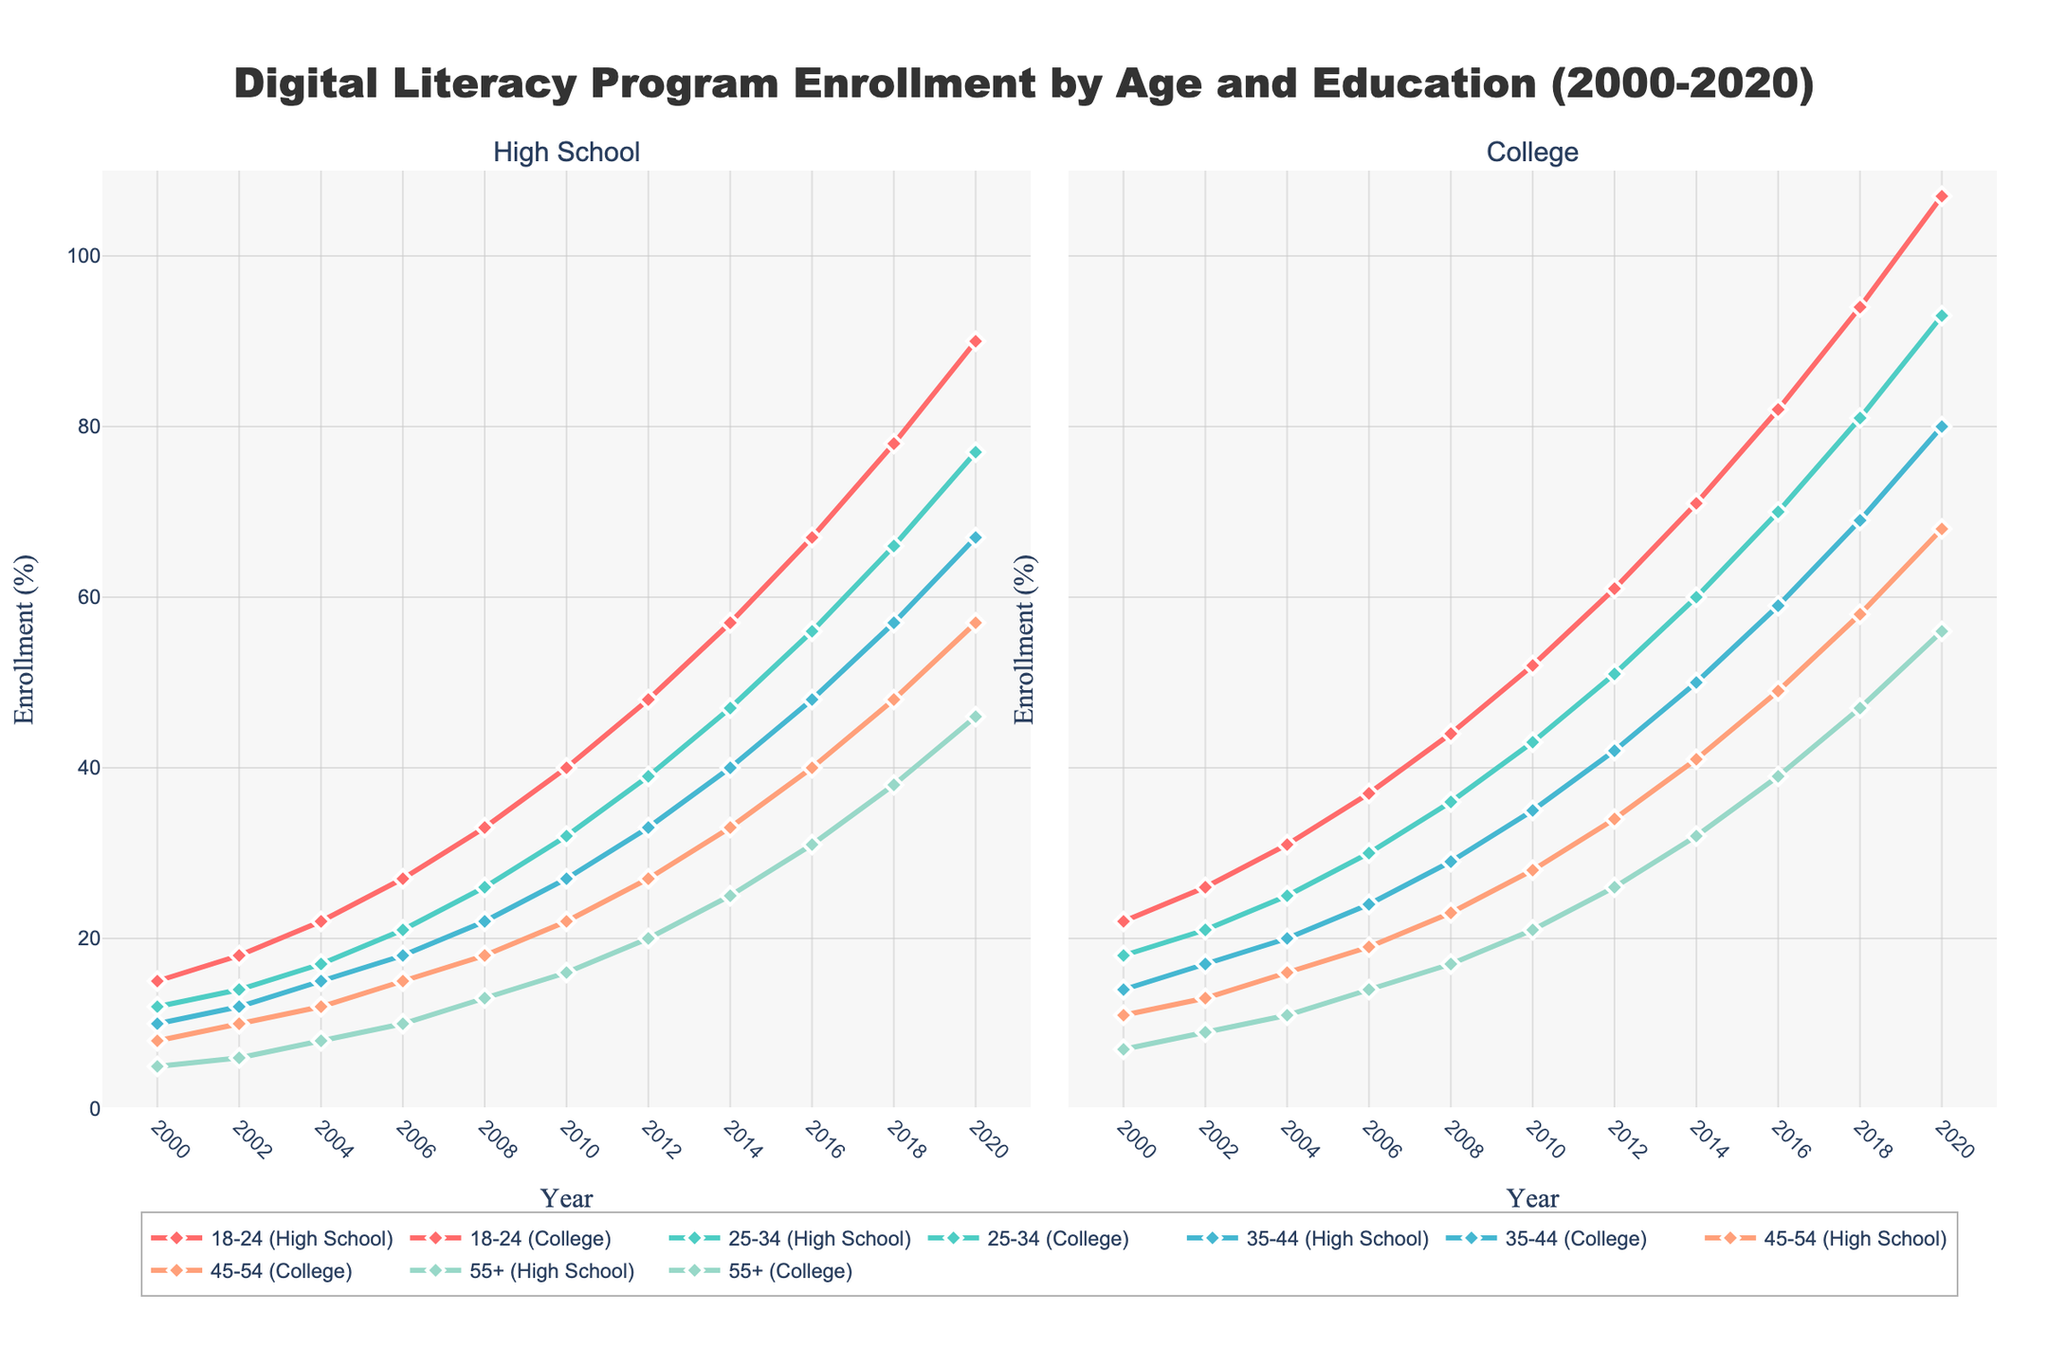What's the enrollment trend for the age group 18-24 with College education from 2000 to 2020? To answer this, look at the trend line for the "18-24 (College)" group over the years 2000 to 2020. Notice if the line is generally increasing, decreasing, or remaining stable. Here, the enrollment trend for this group shows a consistent increase from 22% in 2000 to 107% in 2020.
Answer: Increasing Which age group has the highest enrollment in digital literacy programs in 2020 with a High School education? To answer this, check the 2020 data points for all age groups with High School education. Compare the heights of the 2020 markers for each age group. The age group "18-24 (High School)" has the highest enrollment at 90%.
Answer: 18-24 What's the difference in enrollment between the age groups 35-44 and 55+ with a College education in 2018? To answer this, find the enrollment percentages for 35-44 College (69%) and 55+ College (47%) in 2018, then calculate the difference: 69% - 47% = 22%.
Answer: 22% Across all age groups with either High School or College education, how did the average enrollment change from 2000 to 2010? Calculate the average enrollment for all given groups in 2000 and 2010 separately, then find the difference. 2000: (15+22+12+18+10+14+8+11+5+7)/10 = 12.2; 2010: (40+52+32+43+27+35+22+28+16+21)/10 = 31.6; Change: 31.6 - 12.2 = 19.4.
Answer: 19.4 Which education level (High School or College) saw a greater increase in enrollment for the age group 45-54 from 2000 to 2020? Compare the 2000 and 2020 enrollment percentages for both High School and College education levels for age group 45-54. High School: 57% - 8% = 49%; College: 68% - 11% = 57%. The College education level saw a greater increase.
Answer: College What can you observe about the enrollment percentage for the 55+ age group with a College education between 2000 and 2020? Observe the trend line for the "55+ (College)" group. It shows a consistent increase from 7% in 2000 to 56% in 2020.
Answer: Consistent increase Is there any age group that experienced a decrease in enrollment at any point between 2000 and 2020? Review each trend line for both High School and College education across different age groups for any downward segments. All trend lines show an overall consistent increase with no decreases.
Answer: No What is the combined enrollment percentage for the age groups 18-24 and 25-34 with a College education in 2014? Sum the enrollment percentages of "18-24 (College)" and "25-34 (College)" for the year 2014. (71% + 60% = 131%).
Answer: 131% In 2020, how much higher is the enrollment percentage for the 18-24 age group with a College education compared to the 55+ age group with a High School education? Compare the 2020 enrollment for "18-24 (College)" (107%) and "55+ (High School)" (46%), then find the difference: 107% - 46% = 61%.
Answer: 61% What trend do you observe in the enrollment of digital literacy programs for the age group 25-34 with Double Undergraduate from 2004 to 2008? To answer this, look at the trend lines within this period. Each line displays an upward trend. Also, the increase seems to be quite significant
Answer: Increasing What is the difference between the highest enrollment in 18% with a College for 18-24 year olds in 2010 and High School for the over 55s? The enrollment for the over 55s with a High School education is 16%, so the difference is 88%.
Answer: 88% 